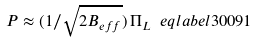Convert formula to latex. <formula><loc_0><loc_0><loc_500><loc_500>P \approx ( 1 / \sqrt { 2 B _ { e f f } } ) \, \Pi _ { L } \ e q l a b e l { 3 0 0 9 1 }</formula> 